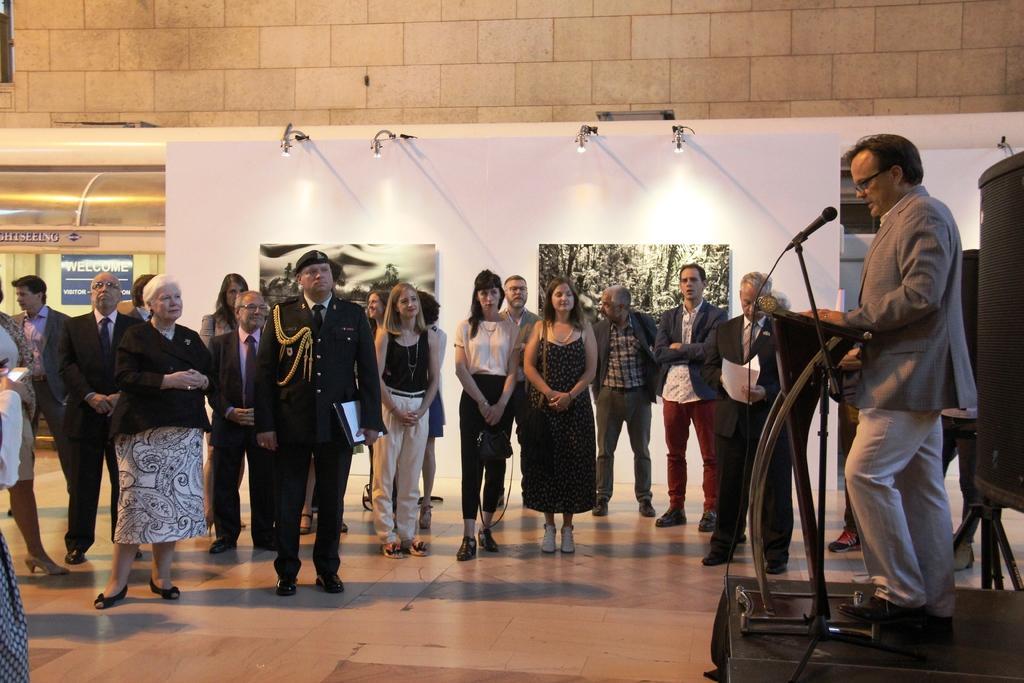Please provide a concise description of this image. In this picture there are few persons standing in the floor in the middle and there is a man standing in front of the podium and there is a mike visible beside the podium on the right side, at the top there is a wall and white color fence and lights visible. 